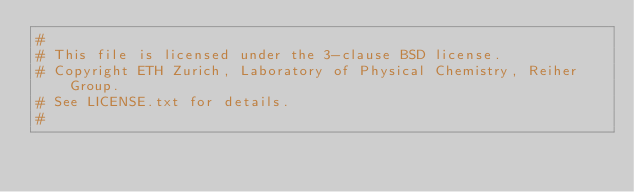<code> <loc_0><loc_0><loc_500><loc_500><_CMake_>#
# This file is licensed under the 3-clause BSD license.
# Copyright ETH Zurich, Laboratory of Physical Chemistry, Reiher Group.
# See LICENSE.txt for details.
#</code> 